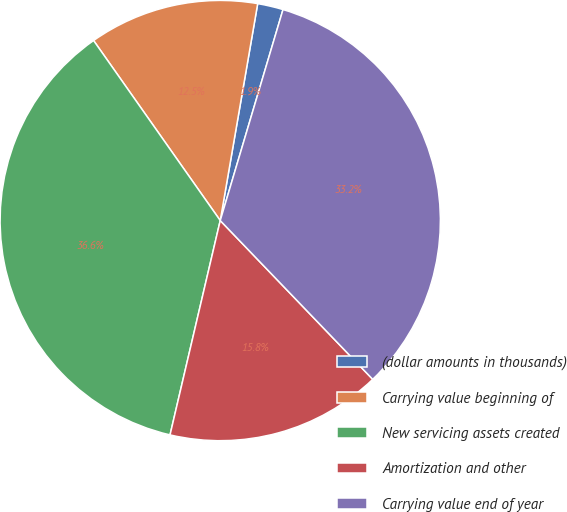Convert chart. <chart><loc_0><loc_0><loc_500><loc_500><pie_chart><fcel>(dollar amounts in thousands)<fcel>Carrying value beginning of<fcel>New servicing assets created<fcel>Amortization and other<fcel>Carrying value end of year<nl><fcel>1.88%<fcel>12.48%<fcel>36.58%<fcel>15.84%<fcel>33.22%<nl></chart> 